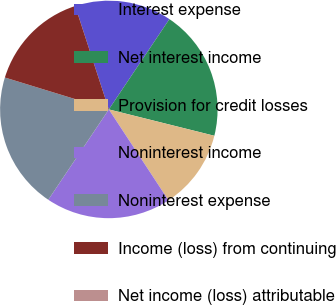<chart> <loc_0><loc_0><loc_500><loc_500><pie_chart><fcel>Interest expense<fcel>Net interest income<fcel>Provision for credit losses<fcel>Noninterest income<fcel>Noninterest expense<fcel>Income (loss) from continuing<fcel>Net income (loss) attributable<nl><fcel>14.41%<fcel>19.49%<fcel>11.86%<fcel>18.64%<fcel>20.34%<fcel>15.25%<fcel>0.0%<nl></chart> 